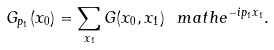Convert formula to latex. <formula><loc_0><loc_0><loc_500><loc_500>G _ { p _ { 1 } } ( x _ { 0 } ) = \sum _ { x _ { 1 } } G ( x _ { 0 } , x _ { 1 } ) \ m a t h e ^ { - i p _ { 1 } x _ { 1 } } .</formula> 